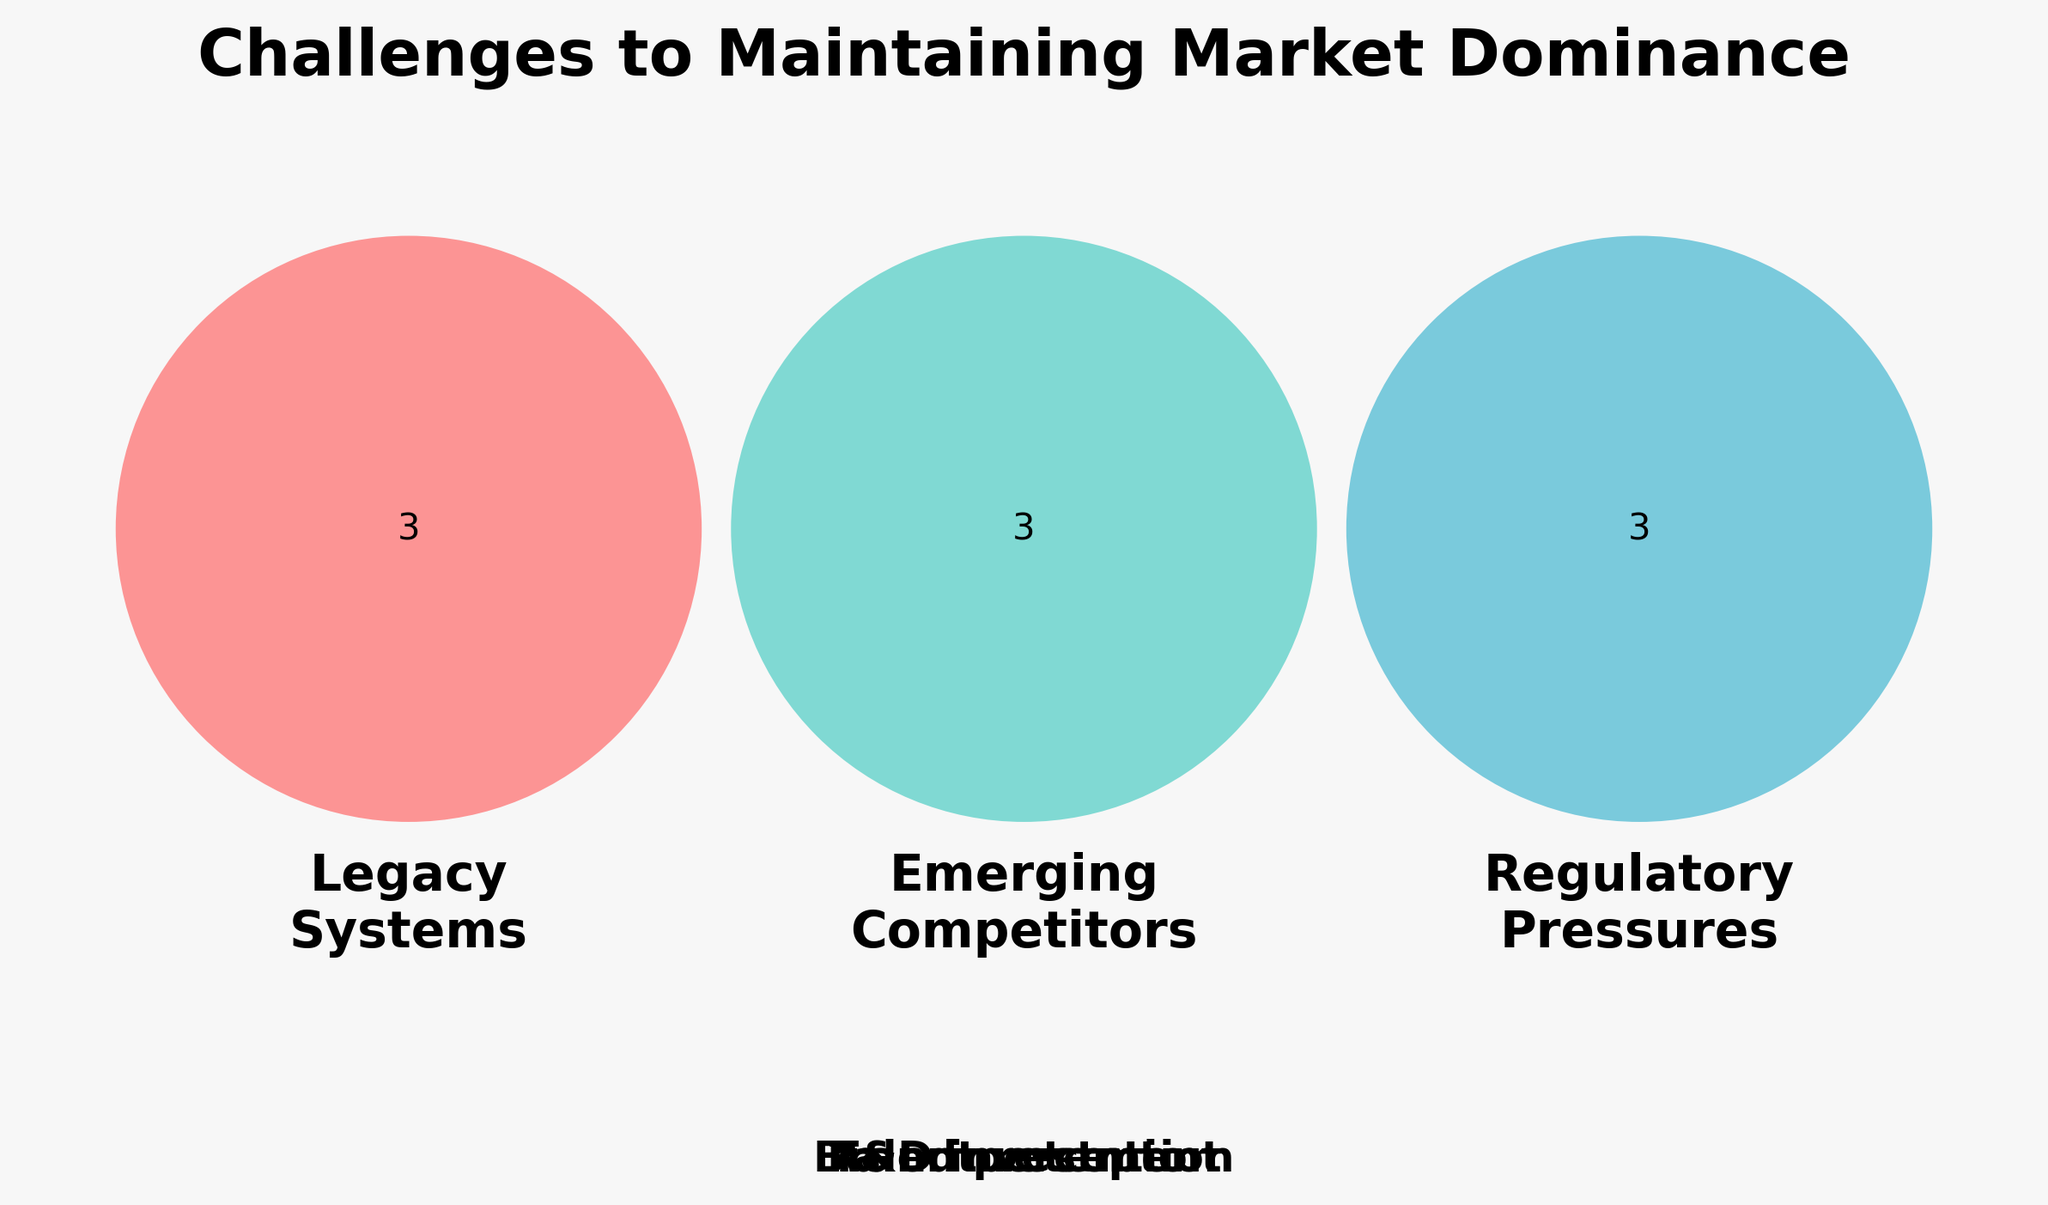what is the title of the figure? The title is given prominently at the top of the figure. It reads "Challenges to Maintaining Market Dominance".
Answer: Challenges to Maintaining Market Dominance How many challenges are listed under 'Legacy Systems'? Count the unique items in the section labeled 'Legacy Systems'. There are three: Outdated infrastructure, Tech debt, Slow innovation.
Answer: 3 Which challenge appears in all three categories? Identify the text placed outside the Venn Diagram but related to all sets. The challenge is Talent retention.
Answer: Talent retention What is the overlap between 'Emerging Competitors' and 'Regulatory Pressures'? Look at the intersection between the sets labeled 'Emerging Competitors' and 'Regulatory Pressures'. There are no overlapping items between them.
Answer: None How many challenges are there in 'All' and also belong to at least one other specific category? Look at the challenges listed in 'All' and check if they appear in 'Legacy Systems', 'Emerging Competitors' or 'Regulatory Pressures'. There are none in the Venn zones overlapping 'All' and any other single specific category (though Brand perception, Talent retention, and R&D investment do belong to 'All').
Answer: 0 Which categories are most affected by tech debt? Identify which part of the Venn Diagram lists tech debt; It appears only under 'Legacy Systems'.
Answer: Legacy Systems Is the challenge 'Brand perception' specific to any one category? Check if 'Brand perception' appears in the section overlapping all categories or just in one part. It belongs to the "All" section, meaning it affects all.
Answer: No What could be an underlying challenge linking 'All' and 'Legacy Systems'? Look at challenges listed under both the 'All' and 'Legacy Systems' sections. Since 'All' covers everything as a common challenge, Talent retention is a linking challenge but appears outside any Venn section, implying it generally affects all categories.
Answer: Talent retention Which category or categories are least impacted by 'Data privacy laws'? Identify the section where 'Data privacy laws' is placed; It only appears under 'Regulatory Pressures', so others are least impacted.
Answer: Legacy Systems, Emerging Competitors 